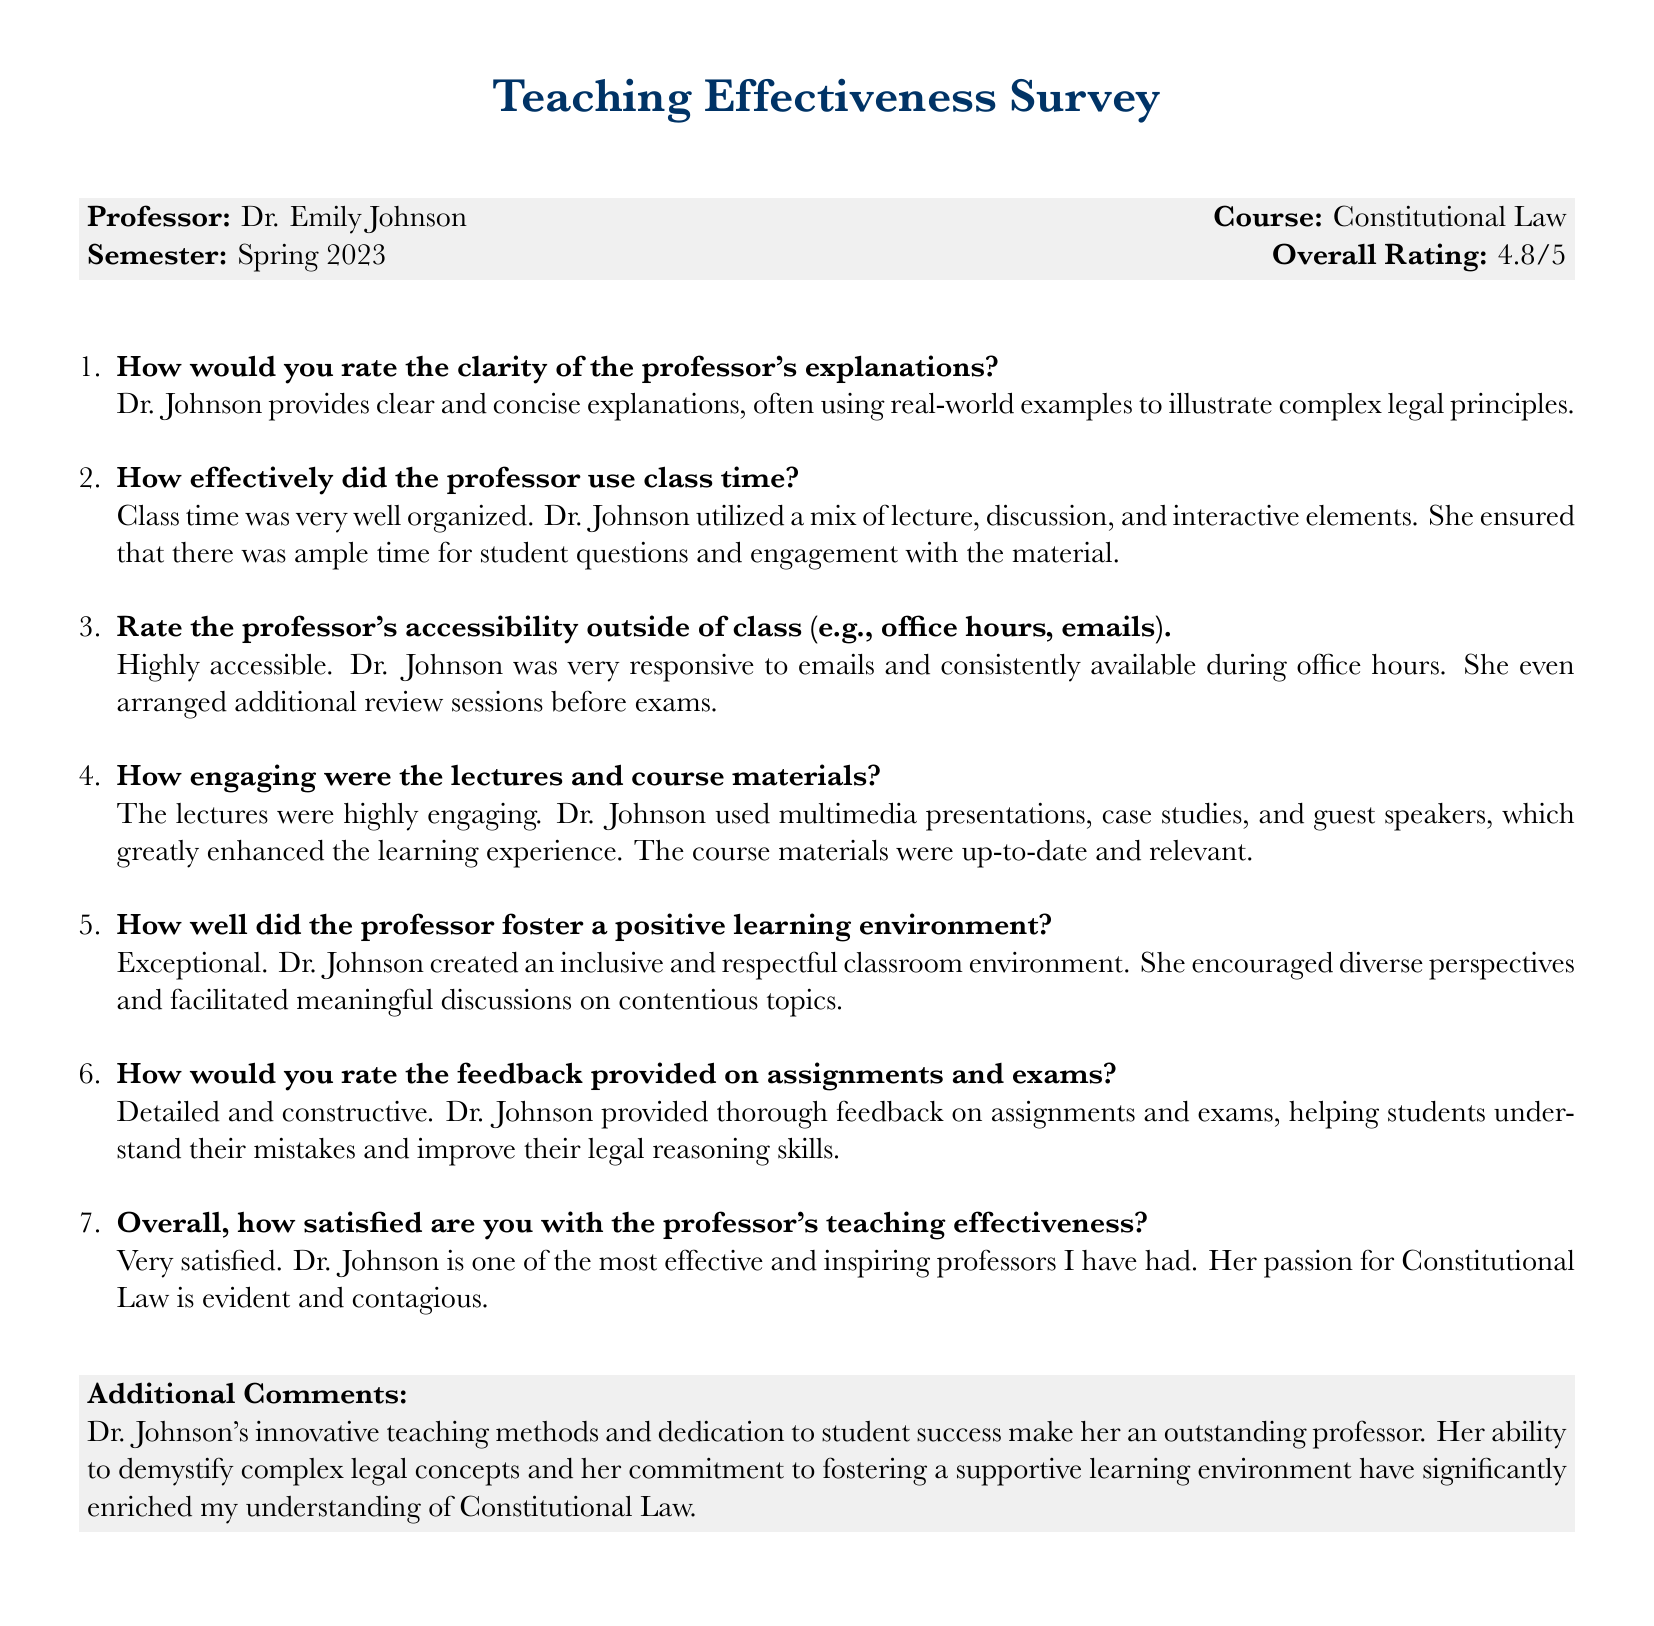What is the professor's name? The document lists the professor as Dr. Emily Johnson.
Answer: Dr. Emily Johnson What course did Dr. Johnson teach? The course taught by Dr. Johnson is specified as Constitutional Law.
Answer: Constitutional Law What was the overall rating given to Dr. Johnson? The overall rating stated in the document is 4.8/5.
Answer: 4.8/5 How did students perceive the clarity of the professor's explanations? Students found Dr. Johnson's explanations clear and concise with real-world examples.
Answer: Clear and concise What kind of learning environment did Dr. Johnson foster? The document indicates Dr. Johnson fostered an inclusive and respectful learning environment.
Answer: Inclusive and respectful How engaging were the course materials? The course materials were described as up-to-date and relevant, making lectures highly engaging.
Answer: Highly engaging What additional support did Dr. Johnson provide to students? Dr. Johnson arranged additional review sessions before exams for her students.
Answer: Additional review sessions What was the nature of the feedback provided on assignments? The feedback provided by Dr. Johnson was detailed and constructive, helping students improve.
Answer: Detailed and constructive What was mentioned as an outstanding characteristic of Dr. Johnson? The document states that her innovative teaching methods and dedication to student success are outstanding.
Answer: Innovative teaching methods 